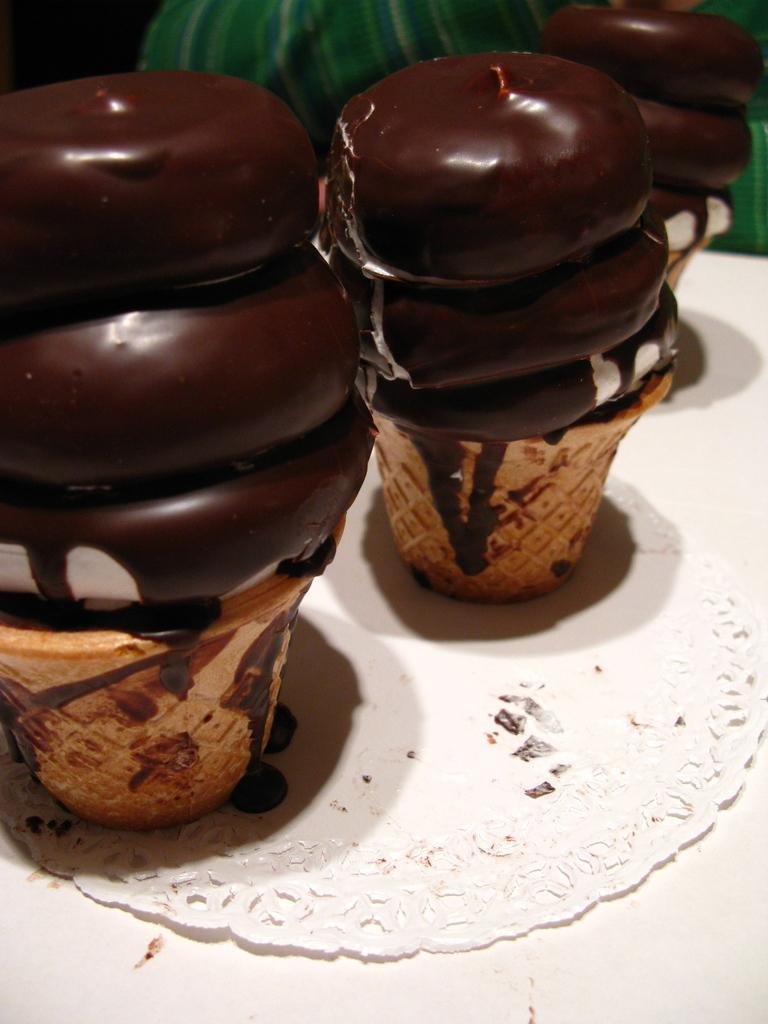What is present on the floor in the image? There is a mat on the floor in the image. What is placed on a white surface in the image? There is food on a white surface in the image. What can be seen in the background of the image? There is a cloth visible in the background of the image. What type of cast can be seen on the beast in the image? There is no beast or cast present in the image. What is the source of shame in the image? There is no shame present in the image. 